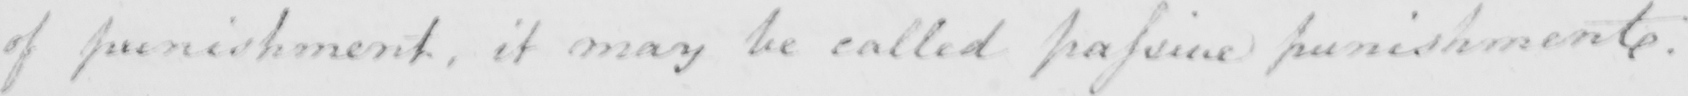What text is written in this handwritten line? of punishment , it may be called passive punishment . 